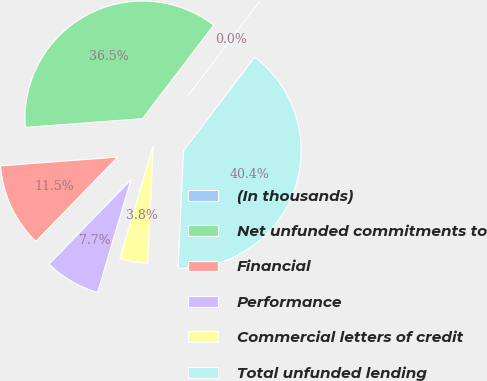Convert chart to OTSL. <chart><loc_0><loc_0><loc_500><loc_500><pie_chart><fcel>(In thousands)<fcel>Net unfunded commitments to<fcel>Financial<fcel>Performance<fcel>Commercial letters of credit<fcel>Total unfunded lending<nl><fcel>0.0%<fcel>36.54%<fcel>11.54%<fcel>7.69%<fcel>3.85%<fcel>40.38%<nl></chart> 